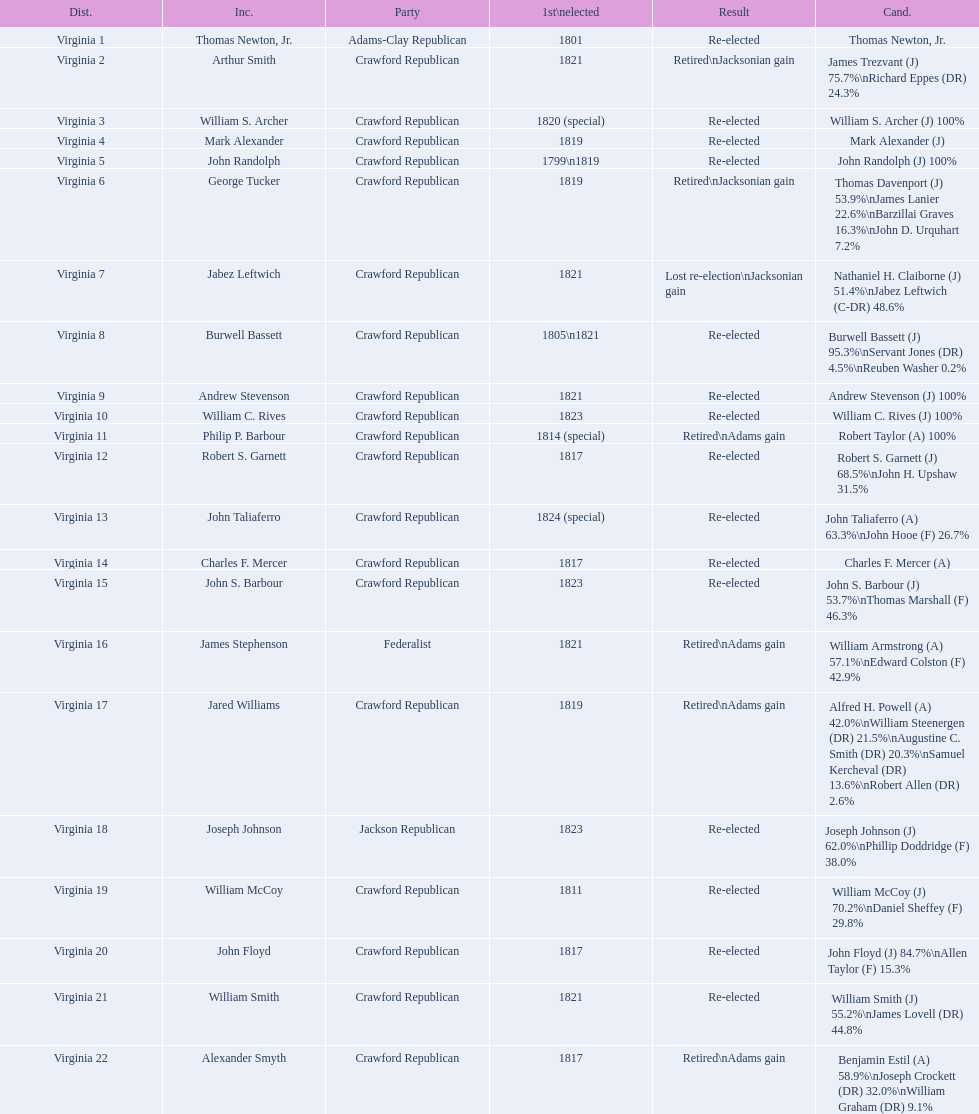What party is a crawford republican? Crawford Republican, Crawford Republican, Crawford Republican, Crawford Republican, Crawford Republican, Crawford Republican, Crawford Republican, Crawford Republican, Crawford Republican, Crawford Republican, Crawford Republican, Crawford Republican, Crawford Republican, Crawford Republican, Crawford Republican, Crawford Republican, Crawford Republican, Crawford Republican, Crawford Republican. What candidates have over 76%? James Trezvant (J) 75.7%\nRichard Eppes (DR) 24.3%, William S. Archer (J) 100%, John Randolph (J) 100%, Burwell Bassett (J) 95.3%\nServant Jones (DR) 4.5%\nReuben Washer 0.2%, Andrew Stevenson (J) 100%, William C. Rives (J) 100%, Robert Taylor (A) 100%, John Floyd (J) 84.7%\nAllen Taylor (F) 15.3%. Which result was retired jacksonian gain? Retired\nJacksonian gain. Who was the incumbent? Arthur Smith. 